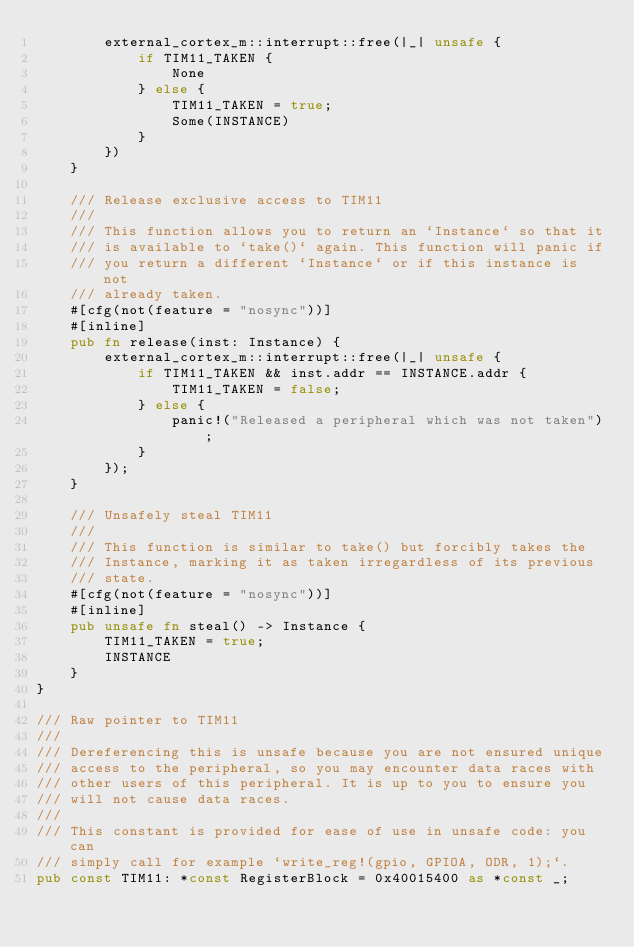Convert code to text. <code><loc_0><loc_0><loc_500><loc_500><_Rust_>        external_cortex_m::interrupt::free(|_| unsafe {
            if TIM11_TAKEN {
                None
            } else {
                TIM11_TAKEN = true;
                Some(INSTANCE)
            }
        })
    }

    /// Release exclusive access to TIM11
    ///
    /// This function allows you to return an `Instance` so that it
    /// is available to `take()` again. This function will panic if
    /// you return a different `Instance` or if this instance is not
    /// already taken.
    #[cfg(not(feature = "nosync"))]
    #[inline]
    pub fn release(inst: Instance) {
        external_cortex_m::interrupt::free(|_| unsafe {
            if TIM11_TAKEN && inst.addr == INSTANCE.addr {
                TIM11_TAKEN = false;
            } else {
                panic!("Released a peripheral which was not taken");
            }
        });
    }

    /// Unsafely steal TIM11
    ///
    /// This function is similar to take() but forcibly takes the
    /// Instance, marking it as taken irregardless of its previous
    /// state.
    #[cfg(not(feature = "nosync"))]
    #[inline]
    pub unsafe fn steal() -> Instance {
        TIM11_TAKEN = true;
        INSTANCE
    }
}

/// Raw pointer to TIM11
///
/// Dereferencing this is unsafe because you are not ensured unique
/// access to the peripheral, so you may encounter data races with
/// other users of this peripheral. It is up to you to ensure you
/// will not cause data races.
///
/// This constant is provided for ease of use in unsafe code: you can
/// simply call for example `write_reg!(gpio, GPIOA, ODR, 1);`.
pub const TIM11: *const RegisterBlock = 0x40015400 as *const _;
</code> 